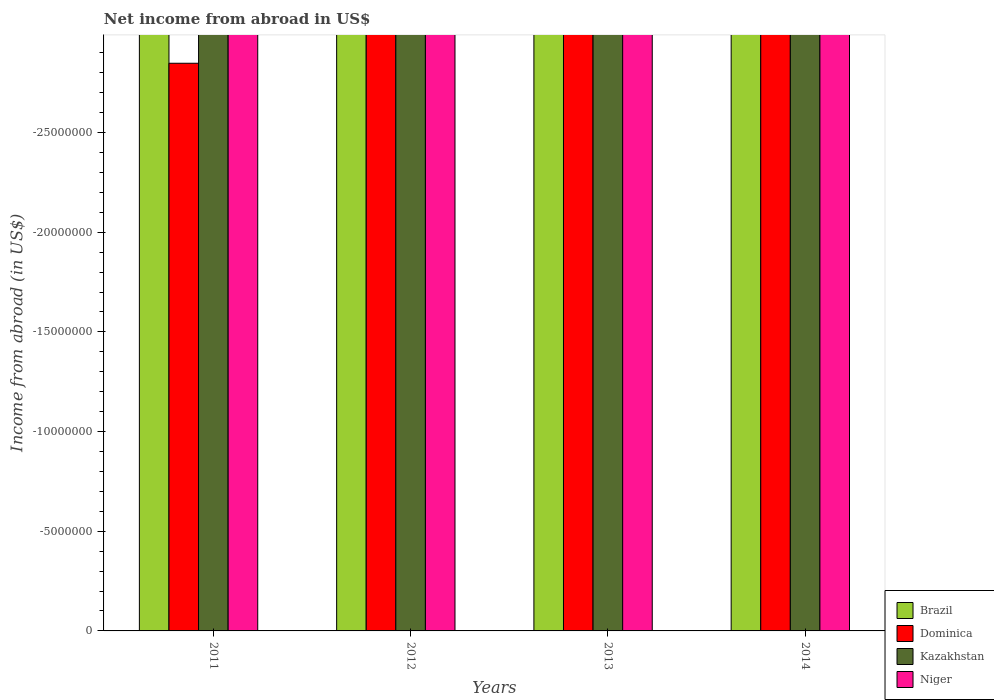How many different coloured bars are there?
Your answer should be very brief. 0. How many bars are there on the 4th tick from the left?
Ensure brevity in your answer.  0. How many bars are there on the 1st tick from the right?
Give a very brief answer. 0. What is the label of the 1st group of bars from the left?
Offer a very short reply. 2011. Across all years, what is the minimum net income from abroad in Dominica?
Keep it short and to the point. 0. What is the total net income from abroad in Brazil in the graph?
Offer a terse response. 0. In how many years, is the net income from abroad in Brazil greater than -21000000 US$?
Offer a very short reply. 0. Is it the case that in every year, the sum of the net income from abroad in Niger and net income from abroad in Brazil is greater than the net income from abroad in Kazakhstan?
Your response must be concise. No. Are all the bars in the graph horizontal?
Keep it short and to the point. No. How many years are there in the graph?
Keep it short and to the point. 4. What is the difference between two consecutive major ticks on the Y-axis?
Ensure brevity in your answer.  5.00e+06. Are the values on the major ticks of Y-axis written in scientific E-notation?
Provide a short and direct response. No. Does the graph contain any zero values?
Your response must be concise. Yes. Where does the legend appear in the graph?
Offer a terse response. Bottom right. How many legend labels are there?
Keep it short and to the point. 4. What is the title of the graph?
Make the answer very short. Net income from abroad in US$. Does "Middle East & North Africa (developing only)" appear as one of the legend labels in the graph?
Keep it short and to the point. No. What is the label or title of the Y-axis?
Ensure brevity in your answer.  Income from abroad (in US$). What is the Income from abroad (in US$) of Dominica in 2011?
Keep it short and to the point. 0. What is the Income from abroad (in US$) in Niger in 2011?
Make the answer very short. 0. What is the Income from abroad (in US$) of Dominica in 2012?
Provide a succinct answer. 0. What is the Income from abroad (in US$) of Kazakhstan in 2012?
Keep it short and to the point. 0. What is the Income from abroad (in US$) of Brazil in 2013?
Ensure brevity in your answer.  0. What is the Income from abroad (in US$) of Niger in 2013?
Provide a succinct answer. 0. What is the Income from abroad (in US$) in Brazil in 2014?
Ensure brevity in your answer.  0. What is the Income from abroad (in US$) in Kazakhstan in 2014?
Your answer should be compact. 0. What is the total Income from abroad (in US$) of Kazakhstan in the graph?
Keep it short and to the point. 0. What is the average Income from abroad (in US$) in Brazil per year?
Offer a very short reply. 0. What is the average Income from abroad (in US$) in Kazakhstan per year?
Offer a very short reply. 0. What is the average Income from abroad (in US$) of Niger per year?
Give a very brief answer. 0. 